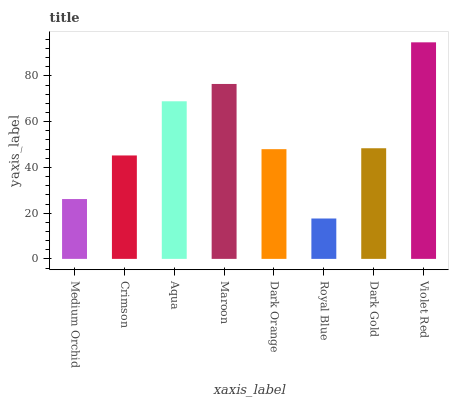Is Royal Blue the minimum?
Answer yes or no. Yes. Is Violet Red the maximum?
Answer yes or no. Yes. Is Crimson the minimum?
Answer yes or no. No. Is Crimson the maximum?
Answer yes or no. No. Is Crimson greater than Medium Orchid?
Answer yes or no. Yes. Is Medium Orchid less than Crimson?
Answer yes or no. Yes. Is Medium Orchid greater than Crimson?
Answer yes or no. No. Is Crimson less than Medium Orchid?
Answer yes or no. No. Is Dark Gold the high median?
Answer yes or no. Yes. Is Dark Orange the low median?
Answer yes or no. Yes. Is Violet Red the high median?
Answer yes or no. No. Is Royal Blue the low median?
Answer yes or no. No. 